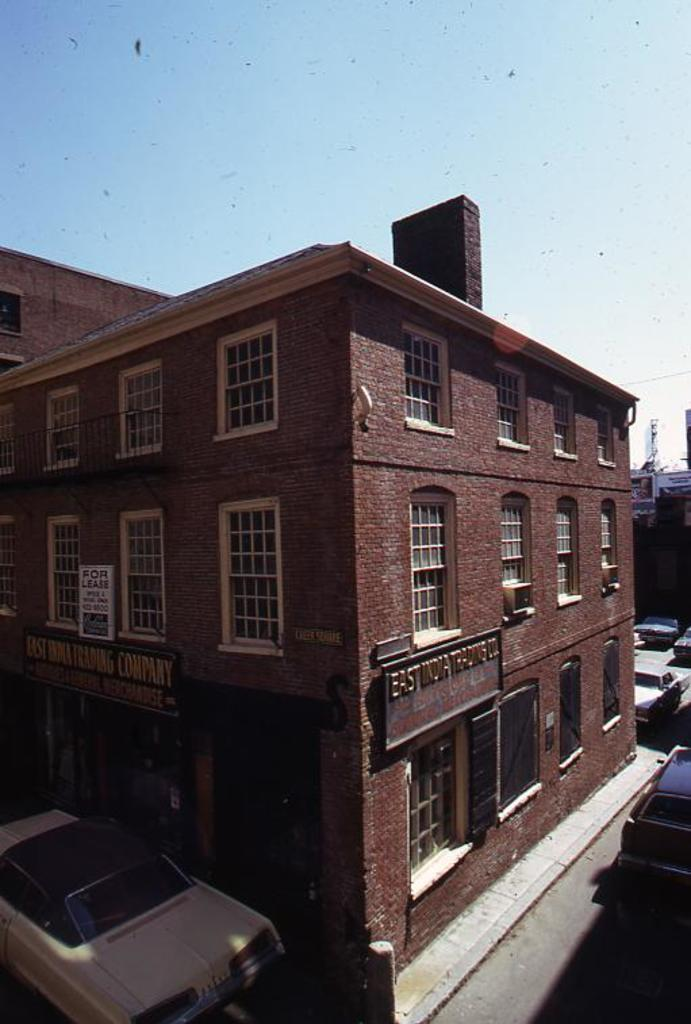What is the color of the building in the image? The building in the image is brown. What is located in front of the building? There is a car parked in front of the building. What can be seen in the background of the image? The sky is visible in the background of the image. How does the tin provide comfort in the image? There is no tin present in the image, so it cannot provide comfort. 